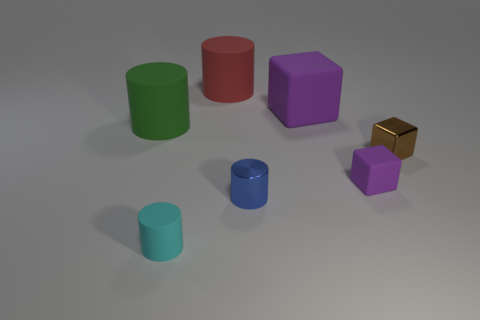Add 2 large spheres. How many objects exist? 9 Subtract all blocks. How many objects are left? 4 Subtract all big purple things. Subtract all big purple objects. How many objects are left? 5 Add 7 tiny cyan rubber things. How many tiny cyan rubber things are left? 8 Add 1 green cylinders. How many green cylinders exist? 2 Subtract 1 green cylinders. How many objects are left? 6 